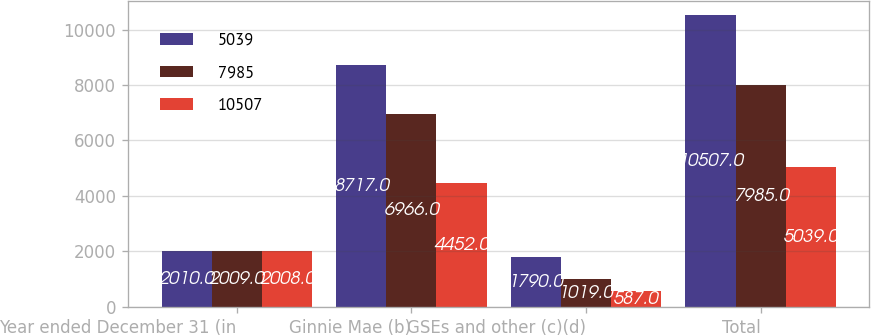Convert chart to OTSL. <chart><loc_0><loc_0><loc_500><loc_500><stacked_bar_chart><ecel><fcel>Year ended December 31 (in<fcel>Ginnie Mae (b)<fcel>GSEs and other (c)(d)<fcel>Total<nl><fcel>5039<fcel>2010<fcel>8717<fcel>1790<fcel>10507<nl><fcel>7985<fcel>2009<fcel>6966<fcel>1019<fcel>7985<nl><fcel>10507<fcel>2008<fcel>4452<fcel>587<fcel>5039<nl></chart> 